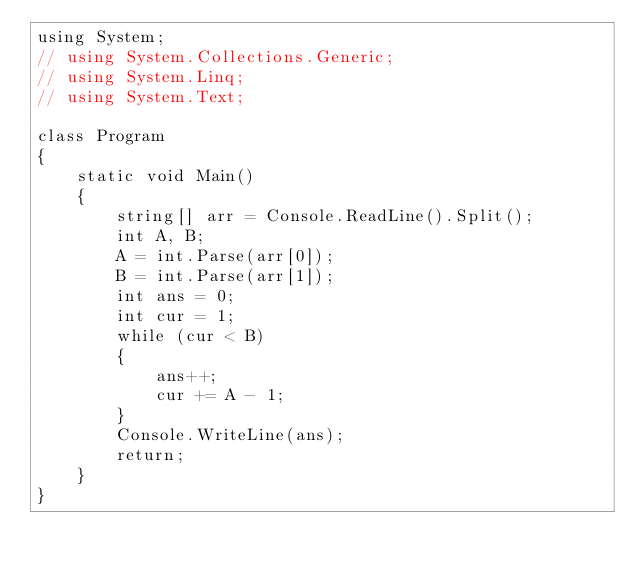<code> <loc_0><loc_0><loc_500><loc_500><_C#_>using System;
// using System.Collections.Generic;
// using System.Linq;
// using System.Text;

class Program
{
    static void Main()
    {
        string[] arr = Console.ReadLine().Split();
        int A, B;
        A = int.Parse(arr[0]);
        B = int.Parse(arr[1]);
        int ans = 0;
        int cur = 1;
        while (cur < B)
        {
            ans++;
            cur += A - 1;
        }
        Console.WriteLine(ans);
        return;
    }
}</code> 